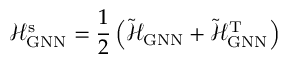Convert formula to latex. <formula><loc_0><loc_0><loc_500><loc_500>\mathcal { H } _ { G N N } ^ { s } = \frac { 1 } { 2 } \left ( \tilde { \mathcal { H } } _ { G N N } + \tilde { \mathcal { H } } _ { G N N } ^ { T } \right )</formula> 